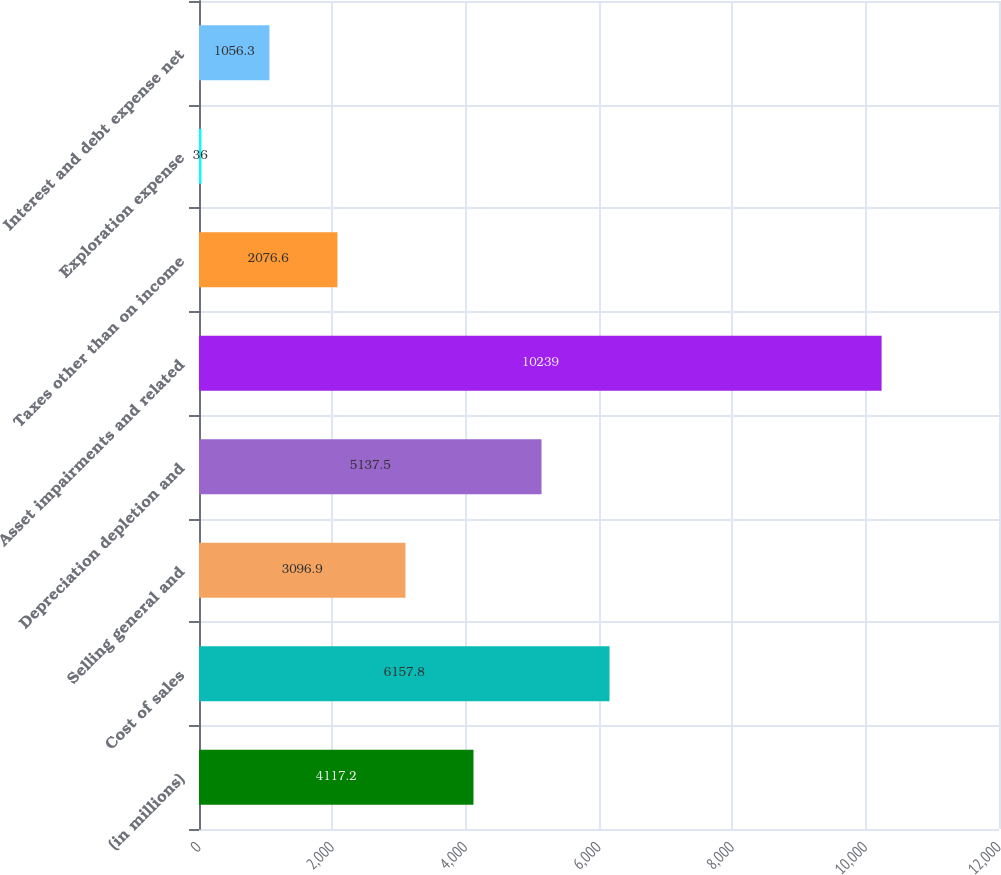Convert chart. <chart><loc_0><loc_0><loc_500><loc_500><bar_chart><fcel>(in millions)<fcel>Cost of sales<fcel>Selling general and<fcel>Depreciation depletion and<fcel>Asset impairments and related<fcel>Taxes other than on income<fcel>Exploration expense<fcel>Interest and debt expense net<nl><fcel>4117.2<fcel>6157.8<fcel>3096.9<fcel>5137.5<fcel>10239<fcel>2076.6<fcel>36<fcel>1056.3<nl></chart> 